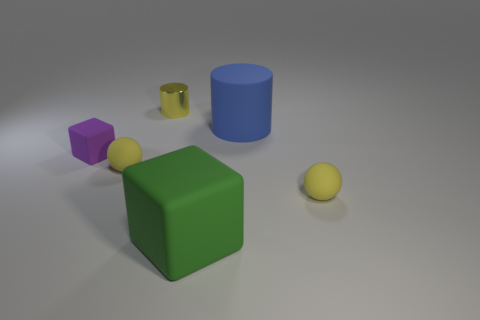Are there any other things that have the same color as the small shiny cylinder? Yes, the small sphere shares the same yellow hue as the small shiny cylinder on the left. Both objects exhibit a similar vibrancy and luster, making them visually cohesive within the scene. 